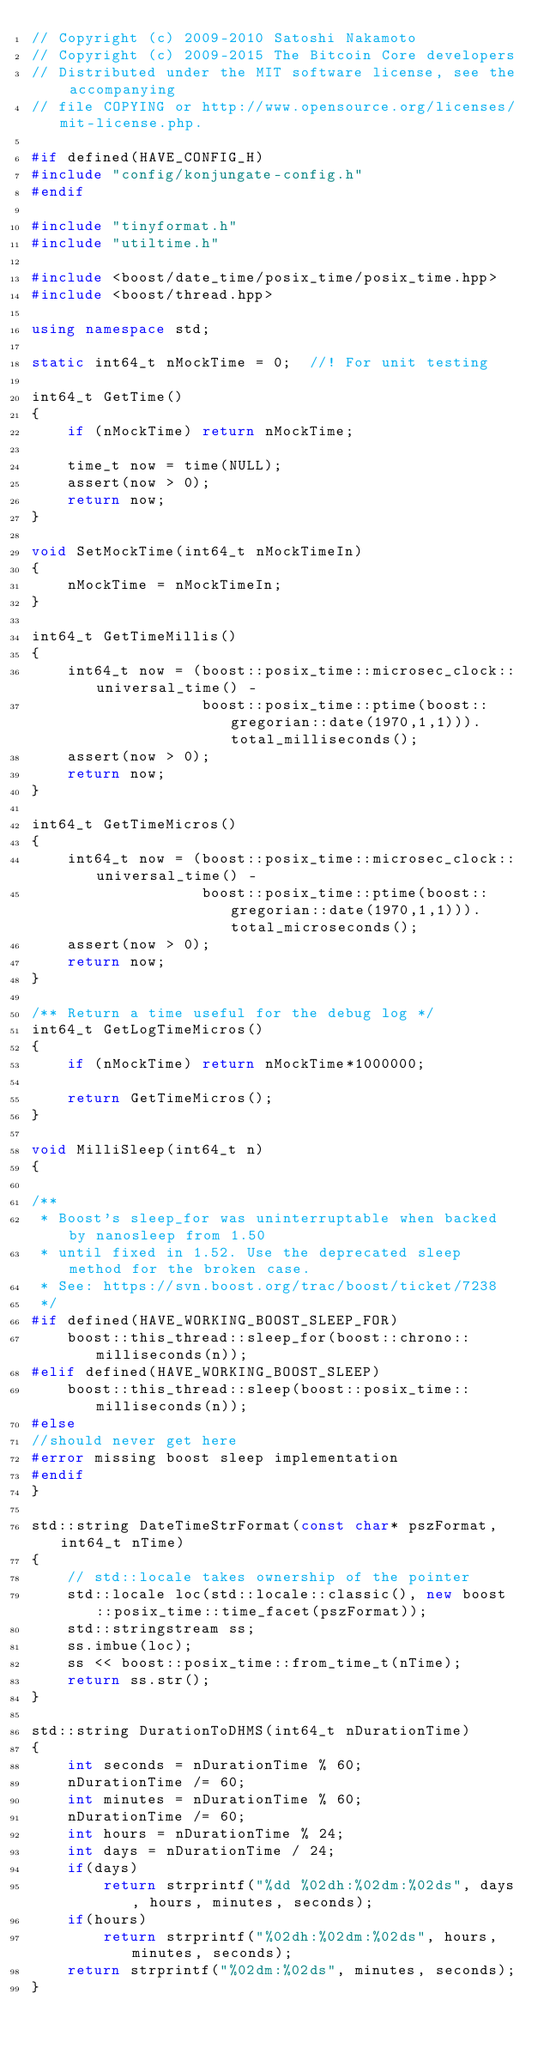Convert code to text. <code><loc_0><loc_0><loc_500><loc_500><_C++_>// Copyright (c) 2009-2010 Satoshi Nakamoto
// Copyright (c) 2009-2015 The Bitcoin Core developers
// Distributed under the MIT software license, see the accompanying
// file COPYING or http://www.opensource.org/licenses/mit-license.php.

#if defined(HAVE_CONFIG_H)
#include "config/konjungate-config.h"
#endif

#include "tinyformat.h"
#include "utiltime.h"

#include <boost/date_time/posix_time/posix_time.hpp>
#include <boost/thread.hpp>

using namespace std;

static int64_t nMockTime = 0;  //! For unit testing

int64_t GetTime()
{
    if (nMockTime) return nMockTime;

    time_t now = time(NULL);
    assert(now > 0);
    return now;
}

void SetMockTime(int64_t nMockTimeIn)
{
    nMockTime = nMockTimeIn;
}

int64_t GetTimeMillis()
{
    int64_t now = (boost::posix_time::microsec_clock::universal_time() -
                   boost::posix_time::ptime(boost::gregorian::date(1970,1,1))).total_milliseconds();
    assert(now > 0);
    return now;
}

int64_t GetTimeMicros()
{
    int64_t now = (boost::posix_time::microsec_clock::universal_time() -
                   boost::posix_time::ptime(boost::gregorian::date(1970,1,1))).total_microseconds();
    assert(now > 0);
    return now;
}

/** Return a time useful for the debug log */
int64_t GetLogTimeMicros()
{
    if (nMockTime) return nMockTime*1000000;

    return GetTimeMicros();
}

void MilliSleep(int64_t n)
{

/**
 * Boost's sleep_for was uninterruptable when backed by nanosleep from 1.50
 * until fixed in 1.52. Use the deprecated sleep method for the broken case.
 * See: https://svn.boost.org/trac/boost/ticket/7238
 */
#if defined(HAVE_WORKING_BOOST_SLEEP_FOR)
    boost::this_thread::sleep_for(boost::chrono::milliseconds(n));
#elif defined(HAVE_WORKING_BOOST_SLEEP)
    boost::this_thread::sleep(boost::posix_time::milliseconds(n));
#else
//should never get here
#error missing boost sleep implementation
#endif
}

std::string DateTimeStrFormat(const char* pszFormat, int64_t nTime)
{
    // std::locale takes ownership of the pointer
    std::locale loc(std::locale::classic(), new boost::posix_time::time_facet(pszFormat));
    std::stringstream ss;
    ss.imbue(loc);
    ss << boost::posix_time::from_time_t(nTime);
    return ss.str();
}

std::string DurationToDHMS(int64_t nDurationTime)
{
    int seconds = nDurationTime % 60;
    nDurationTime /= 60;
    int minutes = nDurationTime % 60;
    nDurationTime /= 60;
    int hours = nDurationTime % 24;
    int days = nDurationTime / 24;
    if(days)
        return strprintf("%dd %02dh:%02dm:%02ds", days, hours, minutes, seconds);
    if(hours)
        return strprintf("%02dh:%02dm:%02ds", hours, minutes, seconds);
    return strprintf("%02dm:%02ds", minutes, seconds);
}
</code> 